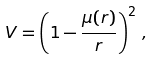Convert formula to latex. <formula><loc_0><loc_0><loc_500><loc_500>V = \left ( 1 - \frac { \mu ( r ) } { r } \right ) ^ { 2 } \, ,</formula> 